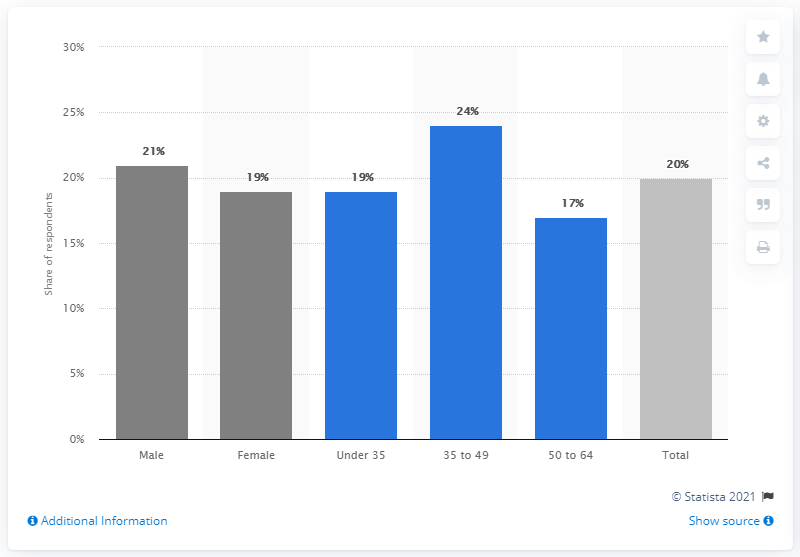Mention a couple of crucial points in this snapshot. The age groups most likely to use a travel app are those between 35 and 49 years old. 